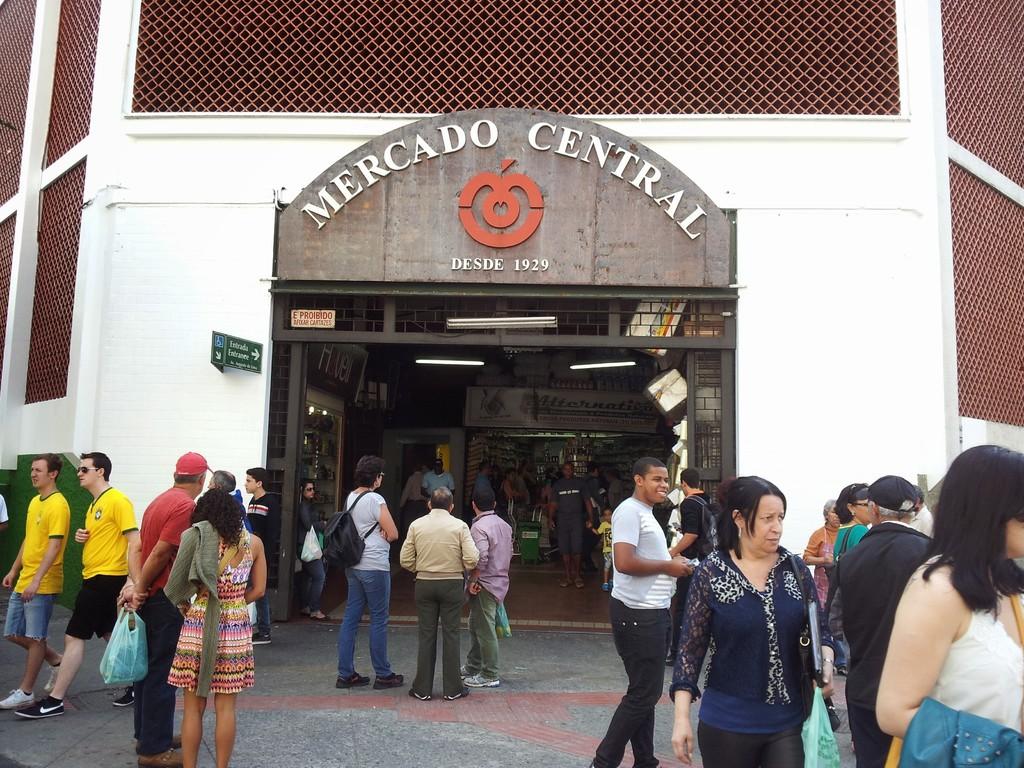Seems like a farmers market to me,does it?
Provide a short and direct response. Unanswerable. What is the market called?
Offer a very short reply. Mercado central. 